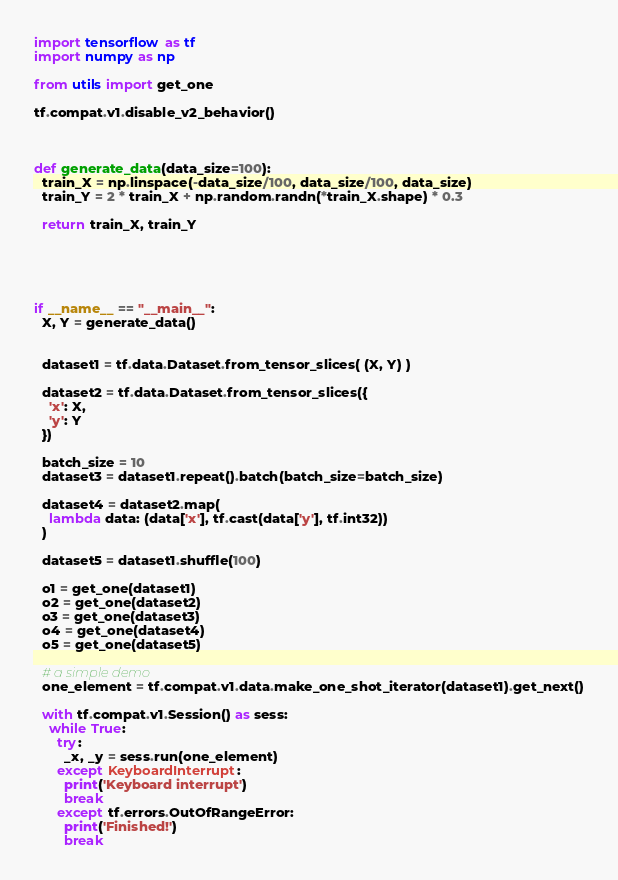Convert code to text. <code><loc_0><loc_0><loc_500><loc_500><_Python_>import tensorflow as tf
import numpy as np

from utils import get_one

tf.compat.v1.disable_v2_behavior()



def generate_data(data_size=100):
  train_X = np.linspace(-data_size/100, data_size/100, data_size)
  train_Y = 2 * train_X + np.random.randn(*train_X.shape) * 0.3

  return train_X, train_Y





if __name__ == "__main__":
  X, Y = generate_data()


  dataset1 = tf.data.Dataset.from_tensor_slices( (X, Y) )

  dataset2 = tf.data.Dataset.from_tensor_slices({
    'x': X,
    'y': Y
  })

  batch_size = 10
  dataset3 = dataset1.repeat().batch(batch_size=batch_size)

  dataset4 = dataset2.map(
    lambda data: (data['x'], tf.cast(data['y'], tf.int32))
  )

  dataset5 = dataset1.shuffle(100)

  o1 = get_one(dataset1)
  o2 = get_one(dataset2)
  o3 = get_one(dataset3)
  o4 = get_one(dataset4)
  o5 = get_one(dataset5)

  # a simple demo 
  one_element = tf.compat.v1.data.make_one_shot_iterator(dataset1).get_next()

  with tf.compat.v1.Session() as sess:
    while True:
      try:
        _x, _y = sess.run(one_element)
      except KeyboardInterrupt:
        print('Keyboard interrupt')
        break
      except tf.errors.OutOfRangeError:
        print('Finished!')
        break


</code> 